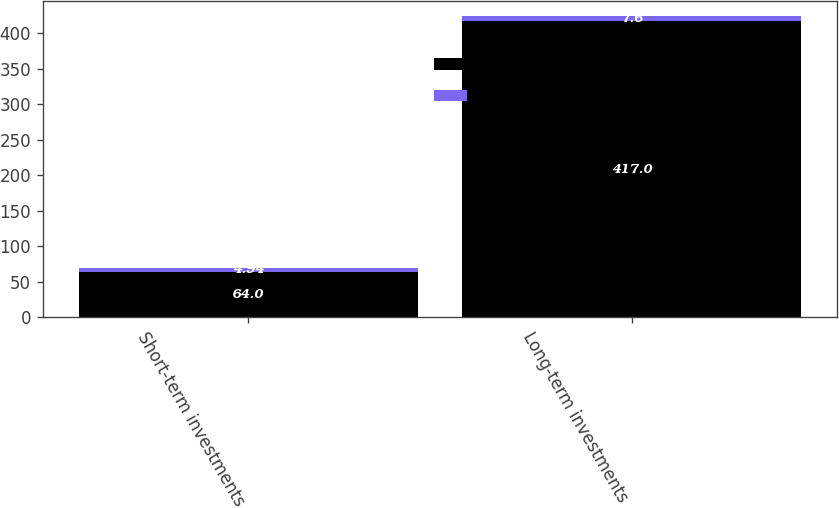Convert chart to OTSL. <chart><loc_0><loc_0><loc_500><loc_500><stacked_bar_chart><ecel><fcel>Short-term investments<fcel>Long-term investments<nl><fcel>Fair Value<fcel>64<fcel>417<nl><fcel>Weighted Average Interest Rate<fcel>4.94<fcel>7.6<nl></chart> 